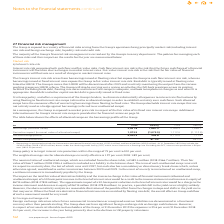According to Intu Properties's financial document, What does interest rate risk comprise of? cash flow and fair value risks. The document states: "erest rate risk Interest rate risk comprises both cash flow and fair value risks. Cash flow interest rate risk is the risk that the future cash flows ..." Also, What is the Group policy? to target interest rate protection within the range of 75 per cent to 100 per cent. The document states: "Group policy is to target interest rate protection within the range of 75 per cent to 100 per cent...." Also, What is the interest rate protection in 2019? According to the financial document, 87.1%. The relevant text states: "Interest rate protection 87.1% 84.2%..." Also, can you calculate: What is the percentage change in the nominal value of unallocated swaps from 2018 to 2019? To answer this question, I need to perform calculations using the financial data. The calculation is: (483.4-566.7)/566.7, which equals -14.7 (percentage). This is based on the information: "aps, which are excluded from the above table, is £483.4 million (2018: £566.7 million). Their fair value of £166.7 million (2018: £184.4 million) is includ d from the above table, is £483.4 million (2..." The key data points involved are: 483.4, 566.7. Also, can you calculate: What is the percentage change in the fair value of unallocated swaps from 2018 to 2019? To answer this question, I need to perform calculations using the financial data. The calculation is: (166.7-184.4)/184.4, which equals -9.6 (percentage). This is based on the information: "lion). Their fair value of £166.7 million (2018: £184.4 million) is included as a liability in the balance sheet. The term of each unallocated swap runs un lion (2018: £566.7 million). Their fair valu..." The key data points involved are: 166.7, 184.4. Also, can you calculate: What is the change in interest rate protection between 2018 and 2019? Based on the calculation: 87.1%-84.2%, the result is 2.9 (percentage). This is based on the information: "Interest rate protection 87.1% 84.2% Interest rate protection 87.1% 84.2%..." The key data points involved are: 84.2, 87.1. 